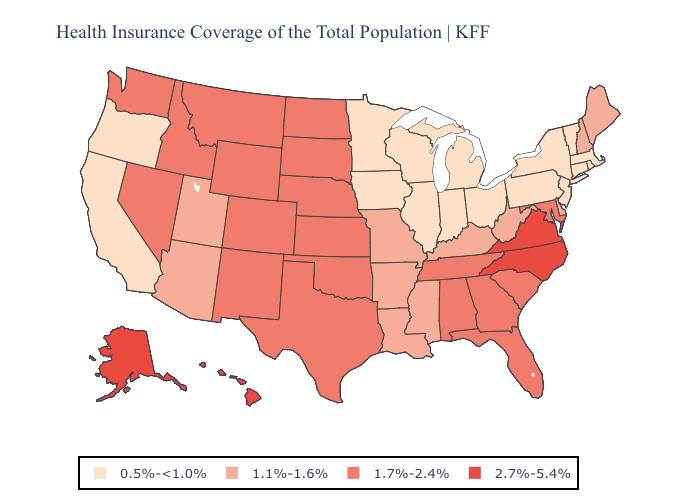What is the lowest value in states that border South Dakota?
Give a very brief answer. 0.5%-<1.0%. Name the states that have a value in the range 0.5%-<1.0%?
Keep it brief. California, Connecticut, Illinois, Indiana, Iowa, Massachusetts, Michigan, Minnesota, New Jersey, New York, Ohio, Oregon, Pennsylvania, Rhode Island, Vermont, Wisconsin. Name the states that have a value in the range 2.7%-5.4%?
Be succinct. Alaska, Hawaii, North Carolina, Virginia. Name the states that have a value in the range 2.7%-5.4%?
Write a very short answer. Alaska, Hawaii, North Carolina, Virginia. What is the highest value in the Northeast ?
Give a very brief answer. 1.1%-1.6%. What is the value of Michigan?
Keep it brief. 0.5%-<1.0%. What is the lowest value in the West?
Keep it brief. 0.5%-<1.0%. Does Nevada have the lowest value in the USA?
Concise answer only. No. Which states have the highest value in the USA?
Concise answer only. Alaska, Hawaii, North Carolina, Virginia. Name the states that have a value in the range 1.7%-2.4%?
Short answer required. Alabama, Colorado, Florida, Georgia, Idaho, Kansas, Maryland, Montana, Nebraska, Nevada, New Mexico, North Dakota, Oklahoma, South Carolina, South Dakota, Tennessee, Texas, Washington, Wyoming. Which states have the highest value in the USA?
Write a very short answer. Alaska, Hawaii, North Carolina, Virginia. Does the map have missing data?
Answer briefly. No. What is the highest value in the MidWest ?
Answer briefly. 1.7%-2.4%. Name the states that have a value in the range 2.7%-5.4%?
Give a very brief answer. Alaska, Hawaii, North Carolina, Virginia. 